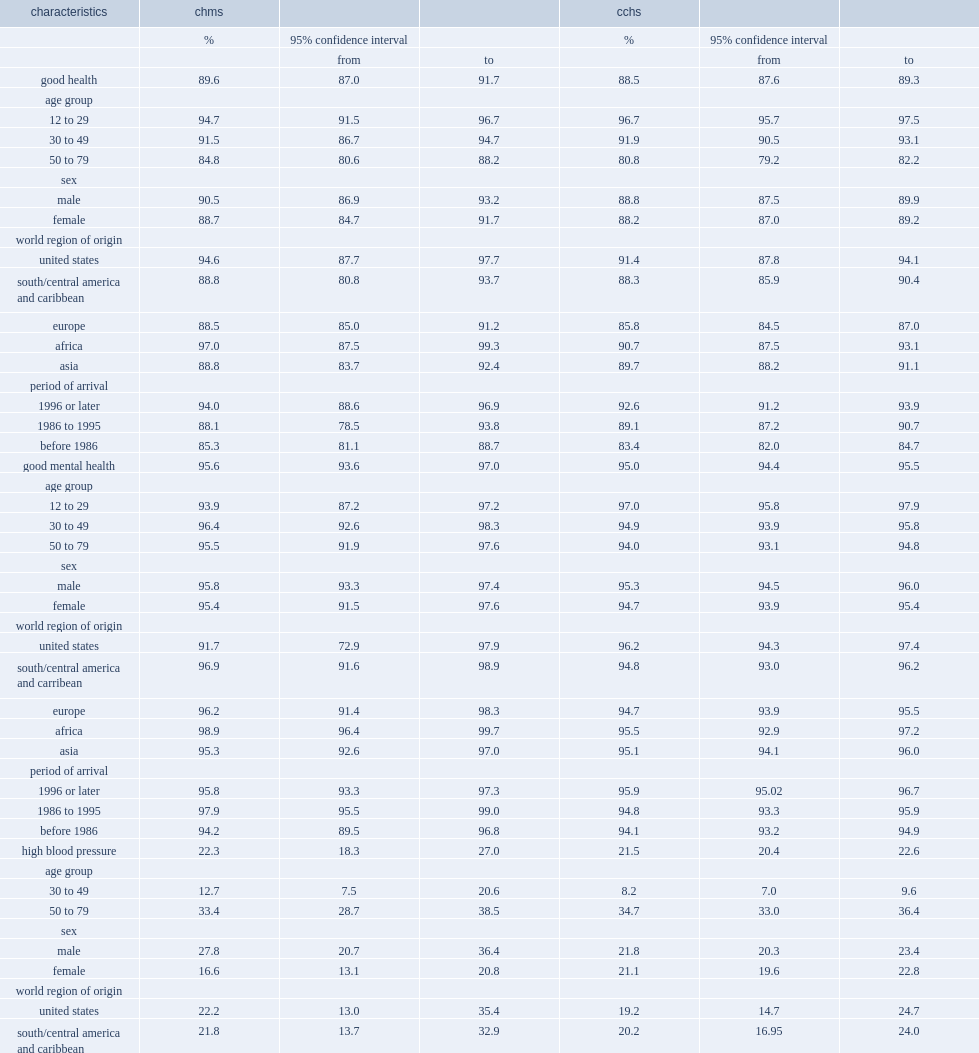What is the prevalence of immigrants reporting good health according to the chms? 89.6. What is the prevalence of immigrants reporting good health according to the cchs? 88.5. What is the prevalence of good health among immigrants aged 50 to 79 based on the chms? 84.8. What is the prevalence of good health among immigrants aged 50 to 79 based on the cchs? 80.8. What is the prevalence of good health among immigrants from africa based on the chms? 97.0. What is the prevalence of good mental health among immigrants based on the chms? 95.6. What is the prevalence of good mental health among immigrants based on the cchs? 95.0. What is the prevalence of immigrants aged 30 to 79 having been diagnosed with high blood pressure according to the chms and cchs survey? 21.9. What is the prevalence of high blood pressure for immigrant women according to the chms? 16.6. What is the prevalence of high blood pressure for immigrant women according to the cchs? 21.1. Could you parse the entire table? {'header': ['characteristics', 'chms', '', '', 'cchs', '', ''], 'rows': [['', '%', '95% confidence interval', '', '%', '95% confidence interval', ''], ['', '', 'from', 'to', '', 'from', 'to'], ['good health', '89.6', '87.0', '91.7', '88.5', '87.6', '89.3'], ['age group', '', '', '', '', '', ''], ['12 to 29', '94.7', '91.5', '96.7', '96.7', '95.7', '97.5'], ['30 to 49', '91.5', '86.7', '94.7', '91.9', '90.5', '93.1'], ['50 to 79', '84.8', '80.6', '88.2', '80.8', '79.2', '82.2'], ['sex', '', '', '', '', '', ''], ['male', '90.5', '86.9', '93.2', '88.8', '87.5', '89.9'], ['female', '88.7', '84.7', '91.7', '88.2', '87.0', '89.2'], ['world region of origin', '', '', '', '', '', ''], ['united states', '94.6', '87.7', '97.7', '91.4', '87.8', '94.1'], ['south/central america and caribbean', '88.8', '80.8', '93.7', '88.3', '85.9', '90.4'], ['europe', '88.5', '85.0', '91.2', '85.8', '84.5', '87.0'], ['africa', '97.0', '87.5', '99.3', '90.7', '87.5', '93.1'], ['asia', '88.8', '83.7', '92.4', '89.7', '88.2', '91.1'], ['period of arrival', '', '', '', '', '', ''], ['1996 or later', '94.0', '88.6', '96.9', '92.6', '91.2', '93.9'], ['1986 to 1995', '88.1', '78.5', '93.8', '89.1', '87.2', '90.7'], ['before 1986', '85.3', '81.1', '88.7', '83.4', '82.0', '84.7'], ['good mental health', '95.6', '93.6', '97.0', '95.0', '94.4', '95.5'], ['age group', '', '', '', '', '', ''], ['12 to 29', '93.9', '87.2', '97.2', '97.0', '95.8', '97.9'], ['30 to 49', '96.4', '92.6', '98.3', '94.9', '93.9', '95.8'], ['50 to 79', '95.5', '91.9', '97.6', '94.0', '93.1', '94.8'], ['sex', '', '', '', '', '', ''], ['male', '95.8', '93.3', '97.4', '95.3', '94.5', '96.0'], ['female', '95.4', '91.5', '97.6', '94.7', '93.9', '95.4'], ['world region of origin', '', '', '', '', '', ''], ['united states', '91.7', '72.9', '97.9', '96.2', '94.3', '97.4'], ['south/central america and carribean', '96.9', '91.6', '98.9', '94.8', '93.0', '96.2'], ['europe', '96.2', '91.4', '98.3', '94.7', '93.9', '95.5'], ['africa', '98.9', '96.4', '99.7', '95.5', '92.9', '97.2'], ['asia', '95.3', '92.6', '97.0', '95.1', '94.1', '96.0'], ['period of arrival', '', '', '', '', '', ''], ['1996 or later', '95.8', '93.3', '97.3', '95.9', '95.02', '96.7'], ['1986 to 1995', '97.9', '95.5', '99.0', '94.8', '93.3', '95.9'], ['before 1986', '94.2', '89.5', '96.8', '94.1', '93.2', '94.9'], ['high blood pressure', '22.3', '18.3', '27.0', '21.5', '20.4', '22.6'], ['age group', '', '', '', '', '', ''], ['30 to 49', '12.7', '7.5', '20.6', '8.2', '7.0', '9.6'], ['50 to 79', '33.4', '28.7', '38.5', '34.7', '33.0', '36.4'], ['sex', '', '', '', '', '', ''], ['male', '27.8', '20.7', '36.4', '21.8', '20.3', '23.4'], ['female', '16.6', '13.1', '20.8', '21.1', '19.6', '22.8'], ['world region of origin', '', '', '', '', '', ''], ['united states', '22.2', '13.0', '35.4', '19.2', '14.7', '24.7'], ['south/central america and caribbean', '21.8', '13.7', '32.9', '20.2', '16.95', '24.0'], ['europe', '27.7', '22.5', '33.5', '26.6', '24.9', '28.4'], ['africa', 'f', '..', '..', '16.1', '12.1', '20.8'], ['asia', '19.9', '12.7', '29.8', '18.4', '16.6', '20.4'], ['period of arrival', '', '', '', '', '', ''], ['1996 or later', '12.8', '6.4', '24.1', '12.8', '10.9', '14.9'], ['1986 to 1995', '16.1', '12.5', '20.4', '18.3', '15.7', '21.2'], ['before 1986', '32.7', '27.8', '38.1', '29.2', '27.7', '30.7']]} 